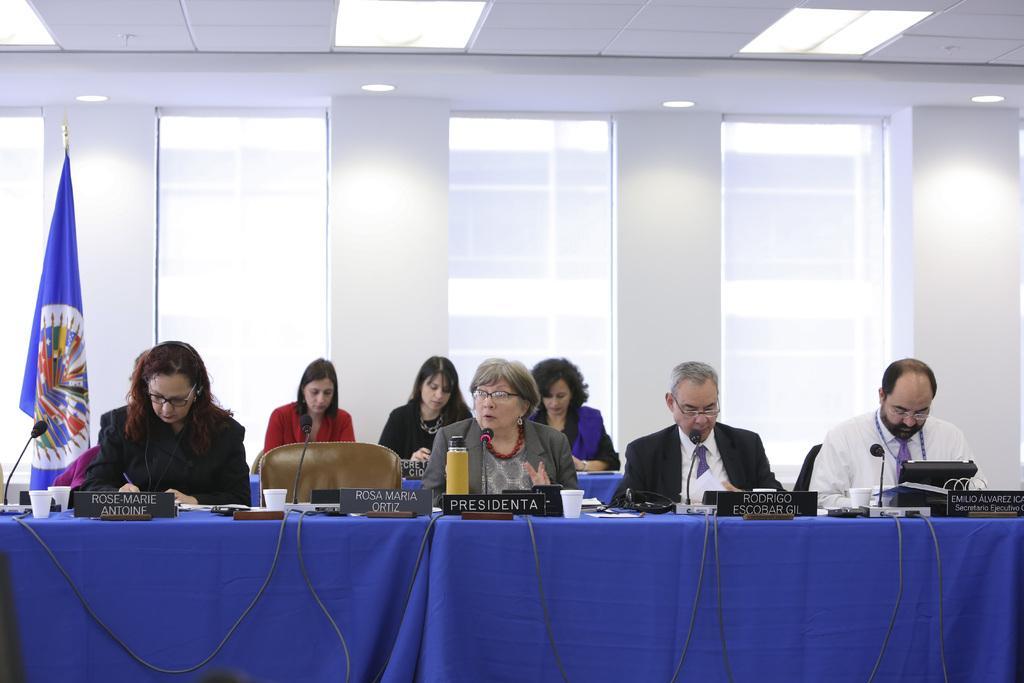Could you give a brief overview of what you see in this image? In the image we can see there are people who are sitting on chair and in front of them there is a table on which there are water bottle, glass and name plates. At the back there is a flag and there are three women sitting on the back. 